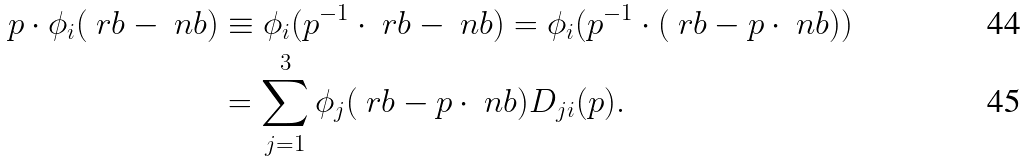Convert formula to latex. <formula><loc_0><loc_0><loc_500><loc_500>p \cdot \phi _ { i } ( \ r b - \ n b ) & \equiv \phi _ { i } ( p ^ { - 1 } \cdot \ r b - \ n b ) = \phi _ { i } ( p ^ { - 1 } \cdot ( \ r b - p \cdot \ n b ) ) \\ & = \sum _ { j = 1 } ^ { 3 } \phi _ { j } ( \ r b - p \cdot \ n b ) D _ { j i } ( p ) .</formula> 